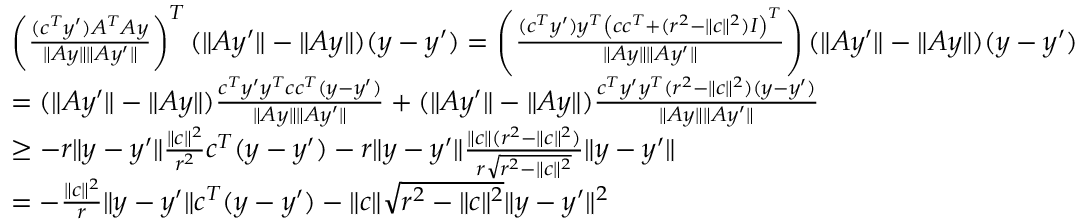Convert formula to latex. <formula><loc_0><loc_0><loc_500><loc_500>\begin{array} { r l r } & { \left ( \frac { ( c ^ { T } y ^ { \prime } ) A ^ { T } A y } { \| A y \| \| A y ^ { \prime } \| } \right ) ^ { T } ( \| A y ^ { \prime } \| - \| A y \| ) ( y - y ^ { \prime } ) = \left ( \frac { ( c ^ { T } y ^ { \prime } ) y ^ { T } \left ( c c ^ { T } + ( r ^ { 2 } - \| c \| ^ { 2 } ) I \right ) ^ { T } } { \| A y \| \| A y ^ { \prime } \| } \right ) ( \| A y ^ { \prime } \| - \| A y \| ) ( y - y ^ { \prime } ) } \\ & { = ( \| A y ^ { \prime } \| - \| A y \| ) \frac { c ^ { T } y ^ { \prime } y ^ { T } c c ^ { T } ( y - y ^ { \prime } ) } { \| A y \| \| A y ^ { \prime } \| } + ( \| A y ^ { \prime } \| - \| A y \| ) \frac { c ^ { T } y ^ { \prime } y ^ { T } ( r ^ { 2 } - \| c \| ^ { 2 } ) ( y - y ^ { \prime } ) } { \| A y \| \| A y ^ { \prime } \| } } \\ & { \geq - r \| y - y ^ { \prime } \| \frac { \| c \| ^ { 2 } } { r ^ { 2 } } c ^ { T } ( y - y ^ { \prime } ) - r \| y - y ^ { \prime } \| \frac { \| c \| ( r ^ { 2 } - \| c \| ^ { 2 } ) } { r \sqrt { r ^ { 2 } - \| c \| ^ { 2 } } } \| y - y ^ { \prime } \| } \\ & { = - \frac { \| c \| ^ { 2 } } { r } \| y - y ^ { \prime } \| c ^ { T } ( y - y ^ { \prime } ) - \| c \| \sqrt { r ^ { 2 } - \| c \| ^ { 2 } } \| y - y ^ { \prime } \| ^ { 2 } } & \end{array}</formula> 